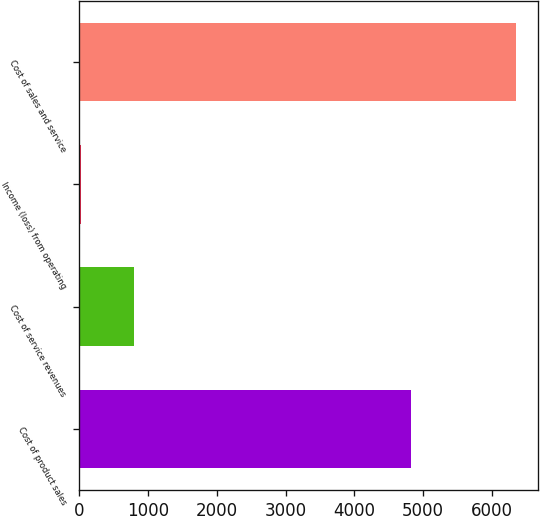Convert chart. <chart><loc_0><loc_0><loc_500><loc_500><bar_chart><fcel>Cost of product sales<fcel>Cost of service revenues<fcel>Income (loss) from operating<fcel>Cost of sales and service<nl><fcel>4827<fcel>802<fcel>18<fcel>6350<nl></chart> 